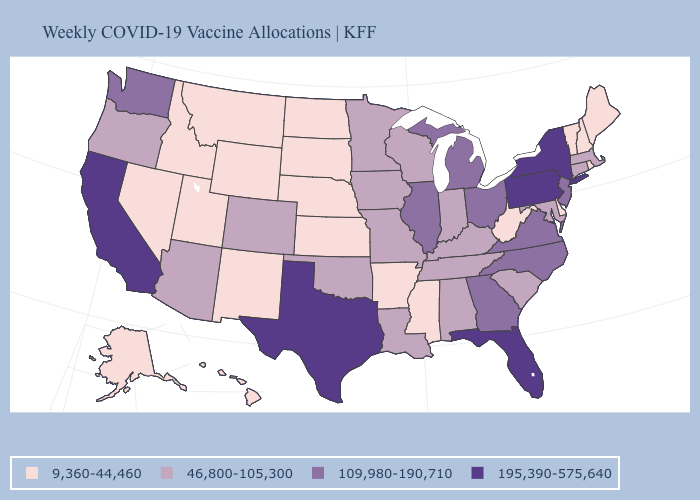Among the states that border South Dakota , which have the highest value?
Quick response, please. Iowa, Minnesota. Name the states that have a value in the range 9,360-44,460?
Short answer required. Alaska, Arkansas, Delaware, Hawaii, Idaho, Kansas, Maine, Mississippi, Montana, Nebraska, Nevada, New Hampshire, New Mexico, North Dakota, Rhode Island, South Dakota, Utah, Vermont, West Virginia, Wyoming. Name the states that have a value in the range 9,360-44,460?
Short answer required. Alaska, Arkansas, Delaware, Hawaii, Idaho, Kansas, Maine, Mississippi, Montana, Nebraska, Nevada, New Hampshire, New Mexico, North Dakota, Rhode Island, South Dakota, Utah, Vermont, West Virginia, Wyoming. What is the value of North Dakota?
Concise answer only. 9,360-44,460. What is the lowest value in the South?
Short answer required. 9,360-44,460. Which states have the lowest value in the USA?
Keep it brief. Alaska, Arkansas, Delaware, Hawaii, Idaho, Kansas, Maine, Mississippi, Montana, Nebraska, Nevada, New Hampshire, New Mexico, North Dakota, Rhode Island, South Dakota, Utah, Vermont, West Virginia, Wyoming. Among the states that border Idaho , does Washington have the lowest value?
Answer briefly. No. What is the lowest value in the USA?
Answer briefly. 9,360-44,460. Name the states that have a value in the range 195,390-575,640?
Quick response, please. California, Florida, New York, Pennsylvania, Texas. Name the states that have a value in the range 195,390-575,640?
Short answer required. California, Florida, New York, Pennsylvania, Texas. What is the lowest value in the USA?
Quick response, please. 9,360-44,460. What is the value of New Jersey?
Write a very short answer. 109,980-190,710. Does Oklahoma have a higher value than Missouri?
Be succinct. No. What is the value of Texas?
Keep it brief. 195,390-575,640. Which states have the lowest value in the MidWest?
Write a very short answer. Kansas, Nebraska, North Dakota, South Dakota. 